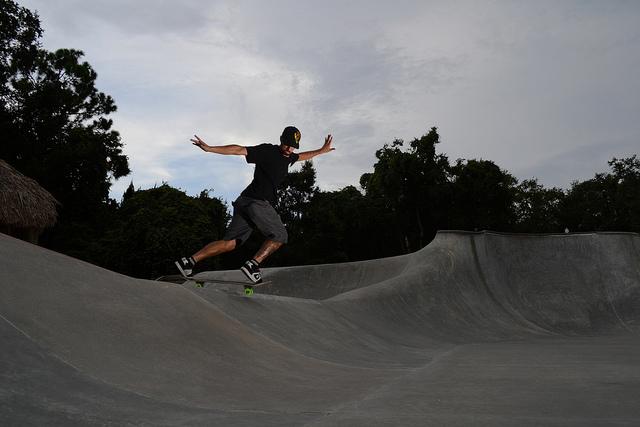Is there anyone else in the picture?
Answer briefly. No. Is the skater good at the sport?
Concise answer only. Yes. What color is the skateboard wheels?
Quick response, please. Green. Is the skateboarding on the street?
Give a very brief answer. No. Is it a sunny day?
Give a very brief answer. No. Are there cracks in the surface?
Quick response, please. No. Is the man snowboarding?
Be succinct. No. 